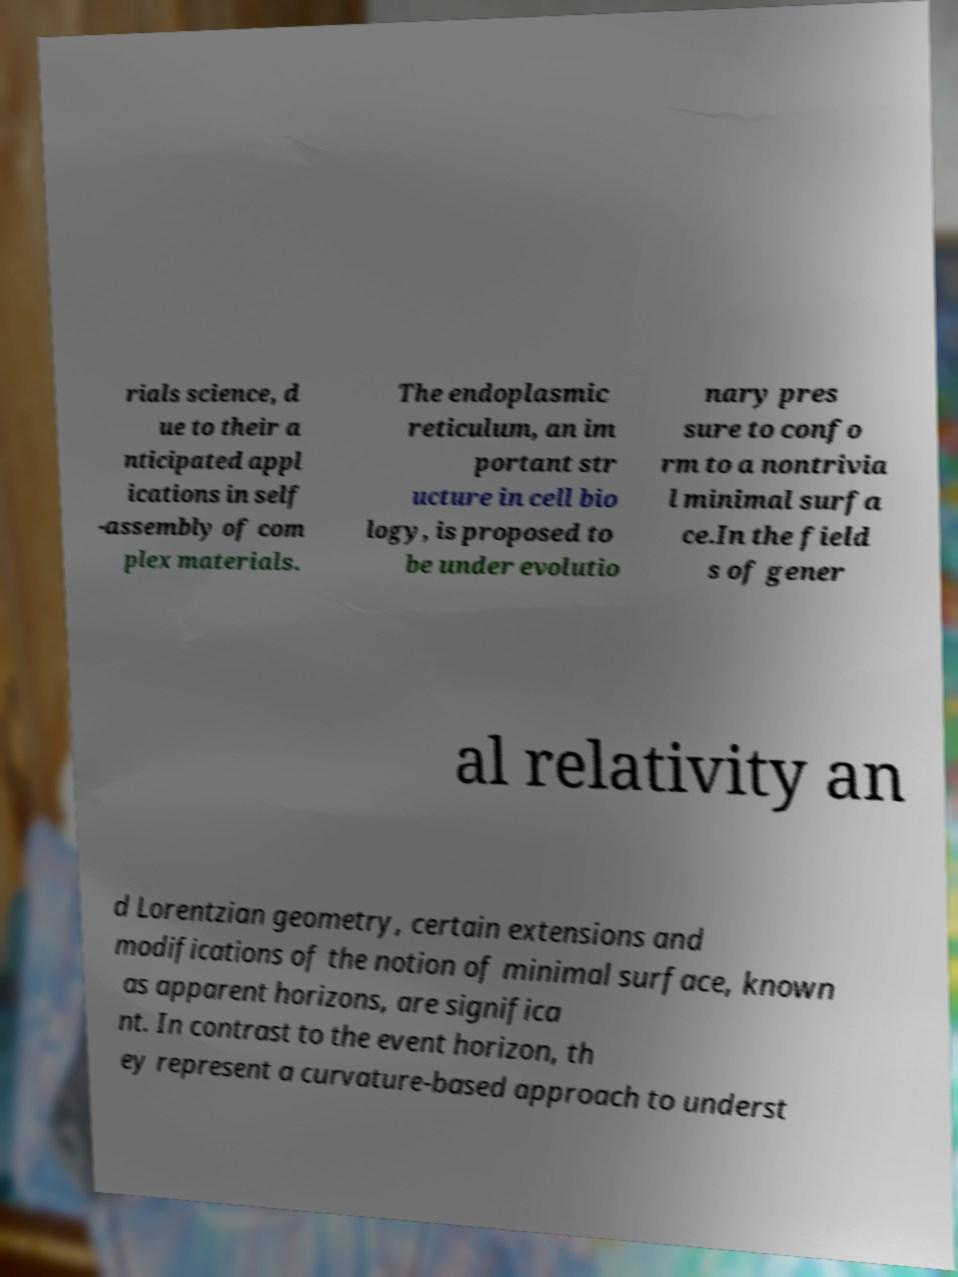Could you extract and type out the text from this image? rials science, d ue to their a nticipated appl ications in self -assembly of com plex materials. The endoplasmic reticulum, an im portant str ucture in cell bio logy, is proposed to be under evolutio nary pres sure to confo rm to a nontrivia l minimal surfa ce.In the field s of gener al relativity an d Lorentzian geometry, certain extensions and modifications of the notion of minimal surface, known as apparent horizons, are significa nt. In contrast to the event horizon, th ey represent a curvature-based approach to underst 